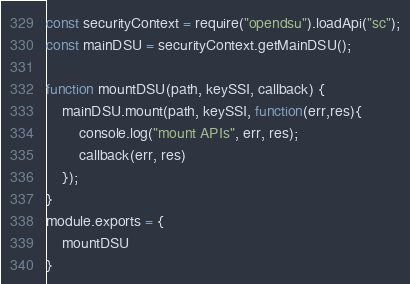<code> <loc_0><loc_0><loc_500><loc_500><_JavaScript_>const securityContext = require("opendsu").loadApi("sc");
const mainDSU = securityContext.getMainDSU();

function mountDSU(path, keySSI, callback) {
    mainDSU.mount(path, keySSI, function(err,res){
        console.log("mount APIs", err, res);
        callback(err, res)
    });
}
module.exports = {
    mountDSU
}</code> 